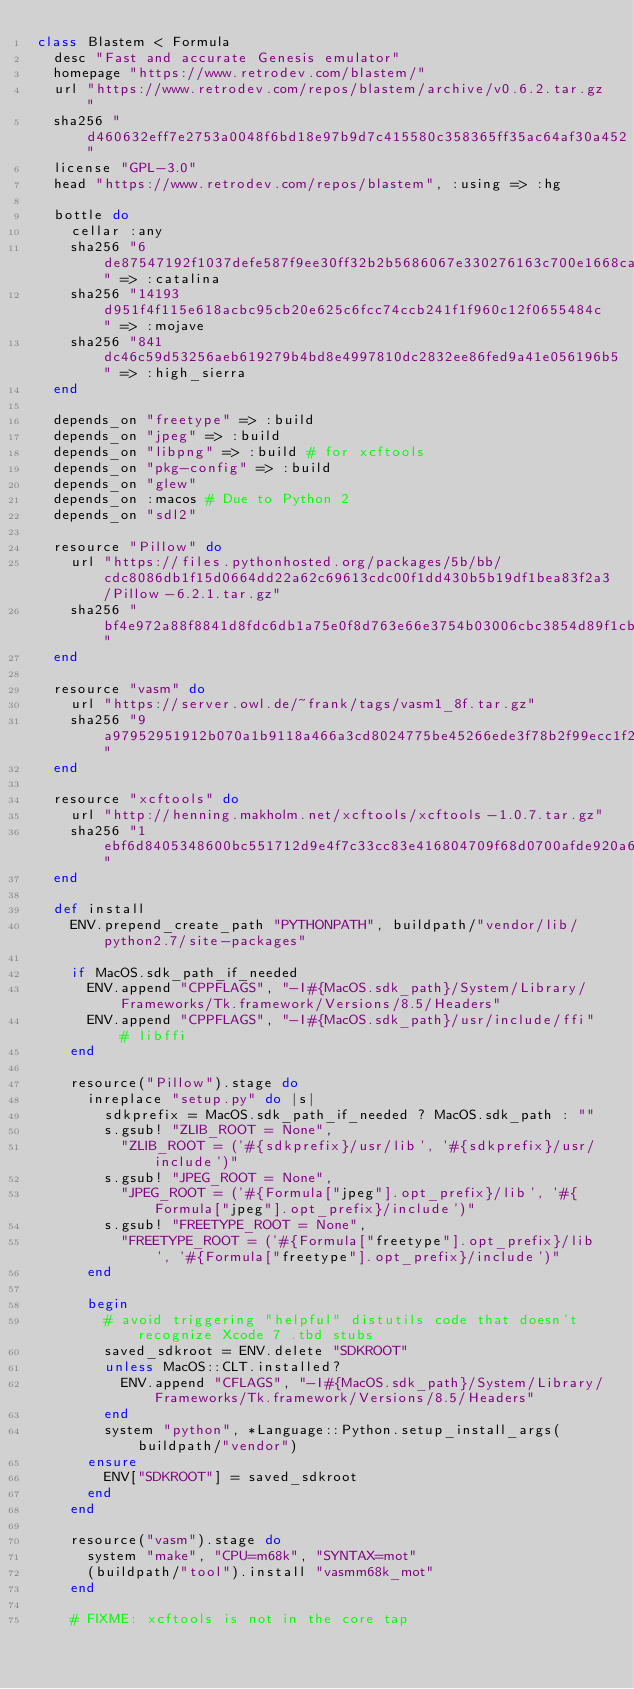<code> <loc_0><loc_0><loc_500><loc_500><_Ruby_>class Blastem < Formula
  desc "Fast and accurate Genesis emulator"
  homepage "https://www.retrodev.com/blastem/"
  url "https://www.retrodev.com/repos/blastem/archive/v0.6.2.tar.gz"
  sha256 "d460632eff7e2753a0048f6bd18e97b9d7c415580c358365ff35ac64af30a452"
  license "GPL-3.0"
  head "https://www.retrodev.com/repos/blastem", :using => :hg

  bottle do
    cellar :any
    sha256 "6de87547192f1037defe587f9ee30ff32b2b5686067e330276163c700e1668ca" => :catalina
    sha256 "14193d951f4f115e618acbc95cb20e625c6fcc74ccb241f1f960c12f0655484c" => :mojave
    sha256 "841dc46c59d53256aeb619279b4bd8e4997810dc2832ee86fed9a41e056196b5" => :high_sierra
  end

  depends_on "freetype" => :build
  depends_on "jpeg" => :build
  depends_on "libpng" => :build # for xcftools
  depends_on "pkg-config" => :build
  depends_on "glew"
  depends_on :macos # Due to Python 2
  depends_on "sdl2"

  resource "Pillow" do
    url "https://files.pythonhosted.org/packages/5b/bb/cdc8086db1f15d0664dd22a62c69613cdc00f1dd430b5b19df1bea83f2a3/Pillow-6.2.1.tar.gz"
    sha256 "bf4e972a88f8841d8fdc6db1a75e0f8d763e66e3754b03006cbc3854d89f1cb1"
  end

  resource "vasm" do
    url "https://server.owl.de/~frank/tags/vasm1_8f.tar.gz"
    sha256 "9a97952951912b070a1b9118a466a3cd8024775be45266ede3f78b2f99ecc1f2"
  end

  resource "xcftools" do
    url "http://henning.makholm.net/xcftools/xcftools-1.0.7.tar.gz"
    sha256 "1ebf6d8405348600bc551712d9e4f7c33cc83e416804709f68d0700afde920a6"
  end

  def install
    ENV.prepend_create_path "PYTHONPATH", buildpath/"vendor/lib/python2.7/site-packages"

    if MacOS.sdk_path_if_needed
      ENV.append "CPPFLAGS", "-I#{MacOS.sdk_path}/System/Library/Frameworks/Tk.framework/Versions/8.5/Headers"
      ENV.append "CPPFLAGS", "-I#{MacOS.sdk_path}/usr/include/ffi" # libffi
    end

    resource("Pillow").stage do
      inreplace "setup.py" do |s|
        sdkprefix = MacOS.sdk_path_if_needed ? MacOS.sdk_path : ""
        s.gsub! "ZLIB_ROOT = None",
          "ZLIB_ROOT = ('#{sdkprefix}/usr/lib', '#{sdkprefix}/usr/include')"
        s.gsub! "JPEG_ROOT = None",
          "JPEG_ROOT = ('#{Formula["jpeg"].opt_prefix}/lib', '#{Formula["jpeg"].opt_prefix}/include')"
        s.gsub! "FREETYPE_ROOT = None",
          "FREETYPE_ROOT = ('#{Formula["freetype"].opt_prefix}/lib', '#{Formula["freetype"].opt_prefix}/include')"
      end

      begin
        # avoid triggering "helpful" distutils code that doesn't recognize Xcode 7 .tbd stubs
        saved_sdkroot = ENV.delete "SDKROOT"
        unless MacOS::CLT.installed?
          ENV.append "CFLAGS", "-I#{MacOS.sdk_path}/System/Library/Frameworks/Tk.framework/Versions/8.5/Headers"
        end
        system "python", *Language::Python.setup_install_args(buildpath/"vendor")
      ensure
        ENV["SDKROOT"] = saved_sdkroot
      end
    end

    resource("vasm").stage do
      system "make", "CPU=m68k", "SYNTAX=mot"
      (buildpath/"tool").install "vasmm68k_mot"
    end

    # FIXME: xcftools is not in the core tap</code> 